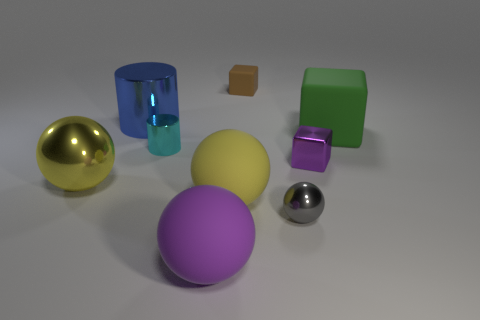What number of other things are there of the same color as the large metallic sphere?
Provide a succinct answer. 1. What is the cylinder that is in front of the blue shiny object made of?
Keep it short and to the point. Metal. Are there any other things that have the same shape as the large purple object?
Give a very brief answer. Yes. What number of metal objects are either large yellow objects or tiny purple blocks?
Offer a terse response. 2. Is the number of purple spheres that are behind the small brown cube less than the number of big yellow rubber objects?
Your answer should be very brief. Yes. What is the shape of the large yellow object that is right of the cylinder in front of the large metal thing behind the tiny cylinder?
Ensure brevity in your answer.  Sphere. Is the number of small brown objects greater than the number of big yellow spheres?
Provide a short and direct response. No. How many other objects are there of the same material as the gray sphere?
Your answer should be compact. 4. How many objects are small purple cylinders or metal balls that are behind the gray metallic sphere?
Your answer should be compact. 1. Are there fewer big matte things than gray shiny spheres?
Keep it short and to the point. No. 